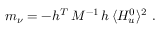<formula> <loc_0><loc_0><loc_500><loc_500>m _ { \nu } = - h ^ { T } \, M ^ { - 1 } \, h \, \langle H _ { u } ^ { 0 } \rangle ^ { 2 } \, .</formula> 